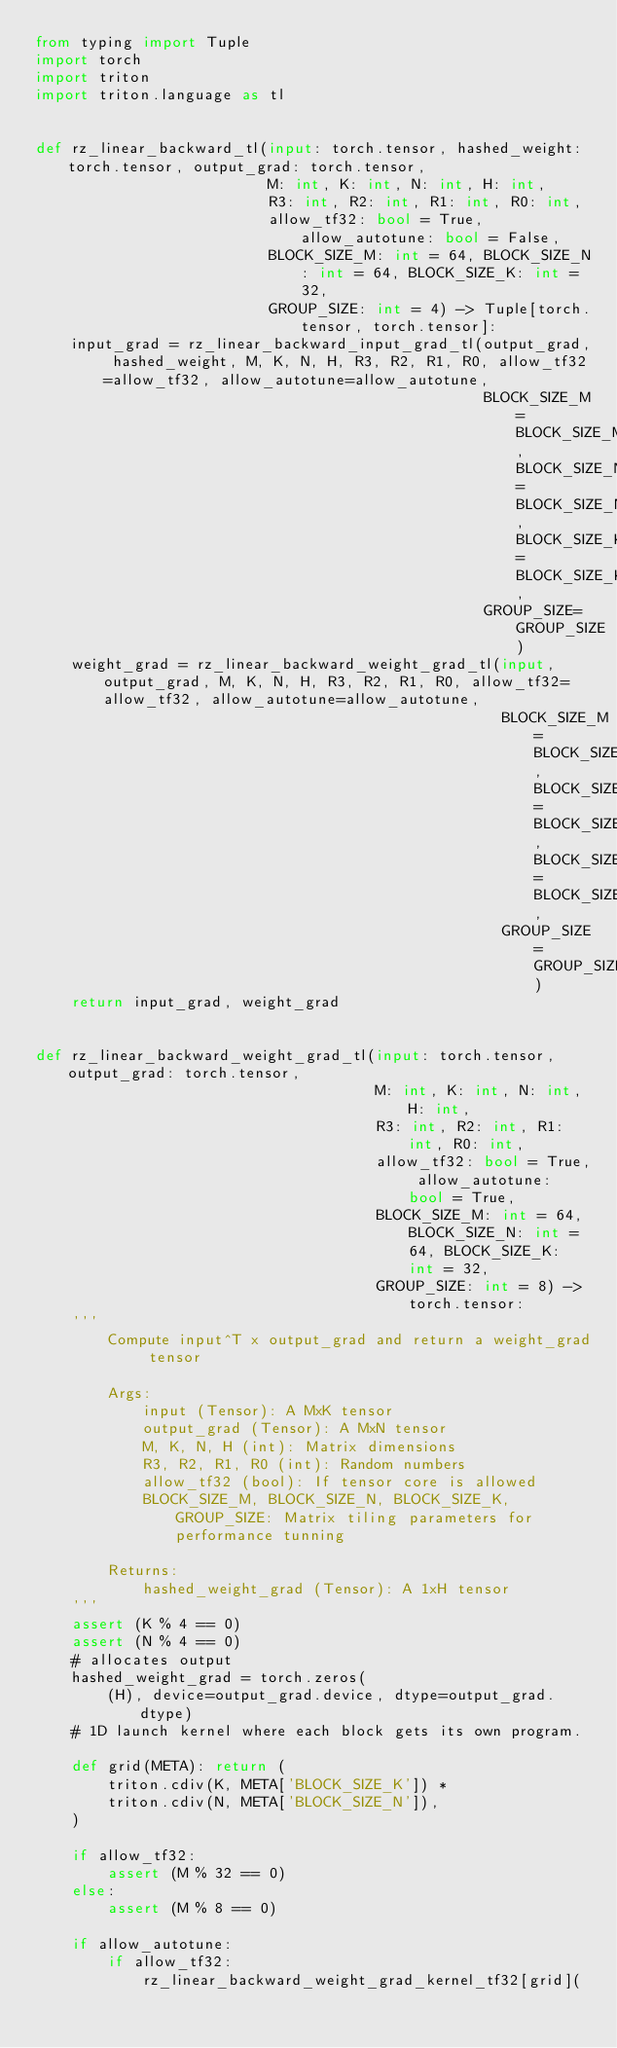Convert code to text. <code><loc_0><loc_0><loc_500><loc_500><_Python_>from typing import Tuple
import torch
import triton
import triton.language as tl


def rz_linear_backward_tl(input: torch.tensor, hashed_weight: torch.tensor, output_grad: torch.tensor,
                          M: int, K: int, N: int, H: int,
                          R3: int, R2: int, R1: int, R0: int,
                          allow_tf32: bool = True, allow_autotune: bool = False,
                          BLOCK_SIZE_M: int = 64, BLOCK_SIZE_N: int = 64, BLOCK_SIZE_K: int = 32,
                          GROUP_SIZE: int = 4) -> Tuple[torch.tensor, torch.tensor]:
    input_grad = rz_linear_backward_input_grad_tl(output_grad, hashed_weight, M, K, N, H, R3, R2, R1, R0, allow_tf32=allow_tf32, allow_autotune=allow_autotune,
                                                  BLOCK_SIZE_M=BLOCK_SIZE_M, BLOCK_SIZE_N=BLOCK_SIZE_N, BLOCK_SIZE_K=BLOCK_SIZE_K,
                                                  GROUP_SIZE=GROUP_SIZE)
    weight_grad = rz_linear_backward_weight_grad_tl(input, output_grad, M, K, N, H, R3, R2, R1, R0, allow_tf32=allow_tf32, allow_autotune=allow_autotune,
                                                    BLOCK_SIZE_M=BLOCK_SIZE_M, BLOCK_SIZE_N=BLOCK_SIZE_N, BLOCK_SIZE_K=BLOCK_SIZE_K,
                                                    GROUP_SIZE=GROUP_SIZE)
    return input_grad, weight_grad


def rz_linear_backward_weight_grad_tl(input: torch.tensor, output_grad: torch.tensor,
                                      M: int, K: int, N: int, H: int,
                                      R3: int, R2: int, R1: int, R0: int,
                                      allow_tf32: bool = True, allow_autotune: bool = True,
                                      BLOCK_SIZE_M: int = 64, BLOCK_SIZE_N: int = 64, BLOCK_SIZE_K: int = 32,
                                      GROUP_SIZE: int = 8) -> torch.tensor:
    '''
        Compute input^T x output_grad and return a weight_grad tensor

        Args:
            input (Tensor): A MxK tensor
            output_grad (Tensor): A MxN tensor
            M, K, N, H (int): Matrix dimensions
            R3, R2, R1, R0 (int): Random numbers
            allow_tf32 (bool): If tensor core is allowed
            BLOCK_SIZE_M, BLOCK_SIZE_N, BLOCK_SIZE_K, GROUP_SIZE: Matrix tiling parameters for performance tunning

        Returns:
            hashed_weight_grad (Tensor): A 1xH tensor
    '''
    assert (K % 4 == 0)
    assert (N % 4 == 0)
    # allocates output
    hashed_weight_grad = torch.zeros(
        (H), device=output_grad.device, dtype=output_grad.dtype)
    # 1D launch kernel where each block gets its own program.

    def grid(META): return (
        triton.cdiv(K, META['BLOCK_SIZE_K']) *
        triton.cdiv(N, META['BLOCK_SIZE_N']),
    )

    if allow_tf32:
        assert (M % 32 == 0)
    else:
        assert (M % 8 == 0)

    if allow_autotune:
        if allow_tf32:
            rz_linear_backward_weight_grad_kernel_tf32[grid](</code> 